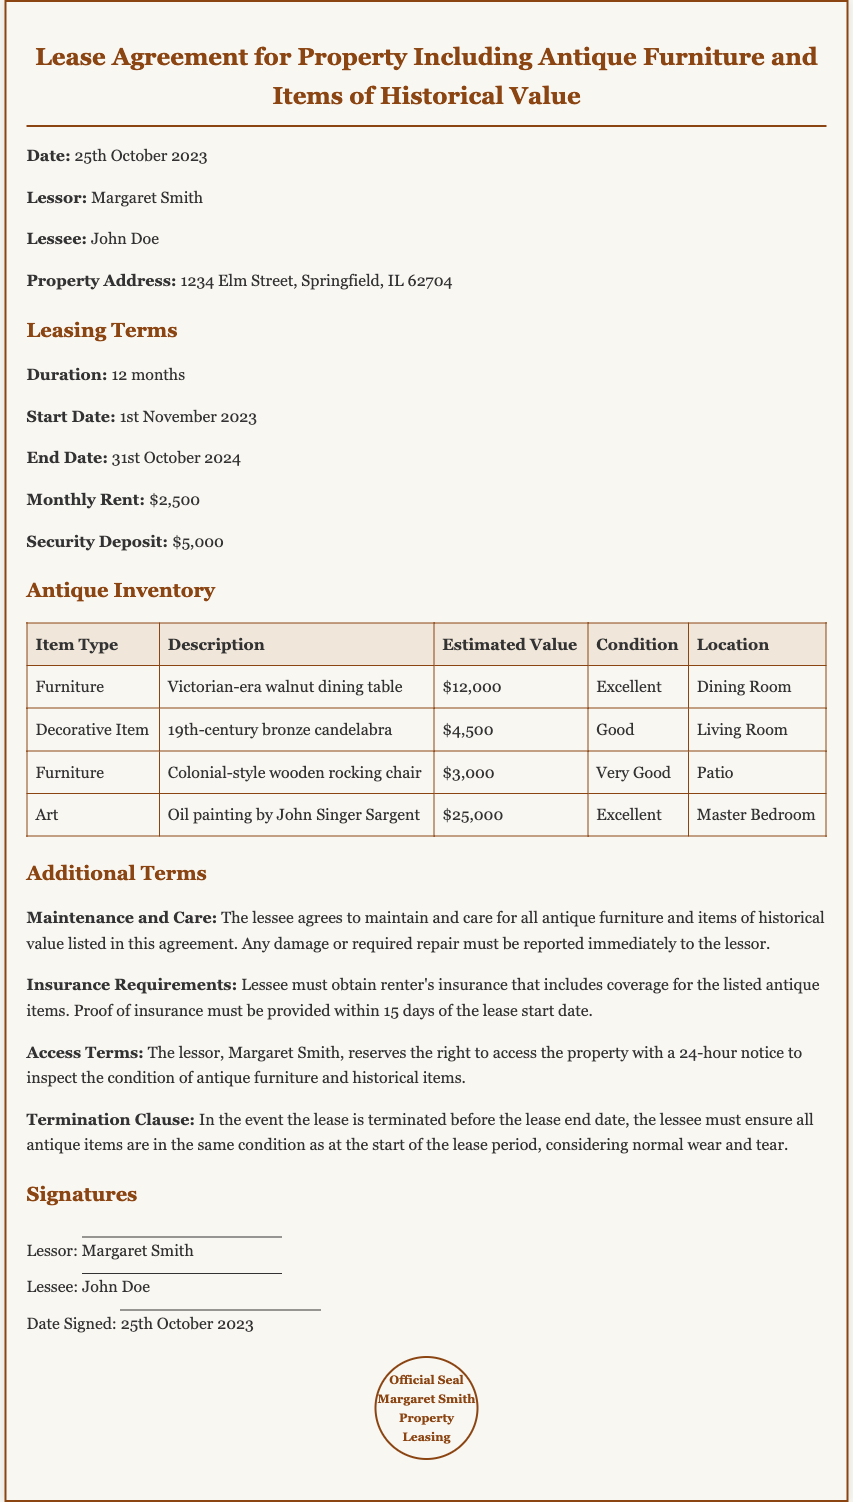What is the duration of the lease? The duration of the lease is specified in the document as 12 months.
Answer: 12 months Who is the lessor? The lessor is identified as Margaret Smith in the document.
Answer: Margaret Smith What is the estimated value of the oil painting? The estimated value of the oil painting is listed in the antique inventory table.
Answer: $25,000 What must the lessee obtain regarding insurance? The document states that the lessee must obtain renter's insurance that includes coverage for the antique items.
Answer: Renter's insurance What happens if the lease is terminated early? The termination clause outlines that the lessee must ensure all antique items are in the same condition as at the start of the lease.
Answer: Same condition What is the location of the Victorian-era walnut dining table? The location of the Victorian-era walnut dining table is indicated in the inventory table.
Answer: Dining Room How much is the security deposit? The security deposit amount is specified under the leasing terms in the document.
Answer: $5,000 What notice period is required for property access by the lessor? The document states that the lessor must provide a 24-hour notice for property access.
Answer: 24 hours 